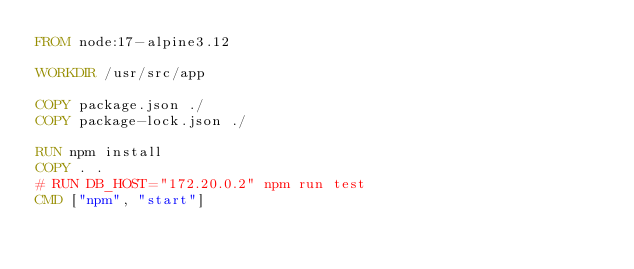Convert code to text. <code><loc_0><loc_0><loc_500><loc_500><_Dockerfile_>FROM node:17-alpine3.12

WORKDIR /usr/src/app

COPY package.json ./
COPY package-lock.json ./

RUN npm install
COPY . .
# RUN DB_HOST="172.20.0.2" npm run test
CMD ["npm", "start"]
</code> 